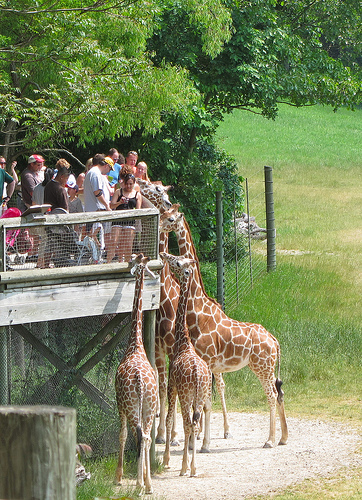What are the people doing behind the giraffes? The people in the image are gathered on a viewing platform, likely observing and admiring the giraffes. It seems to be an interactive area where zoo visitors can get a closer look at these magnificent creatures. 